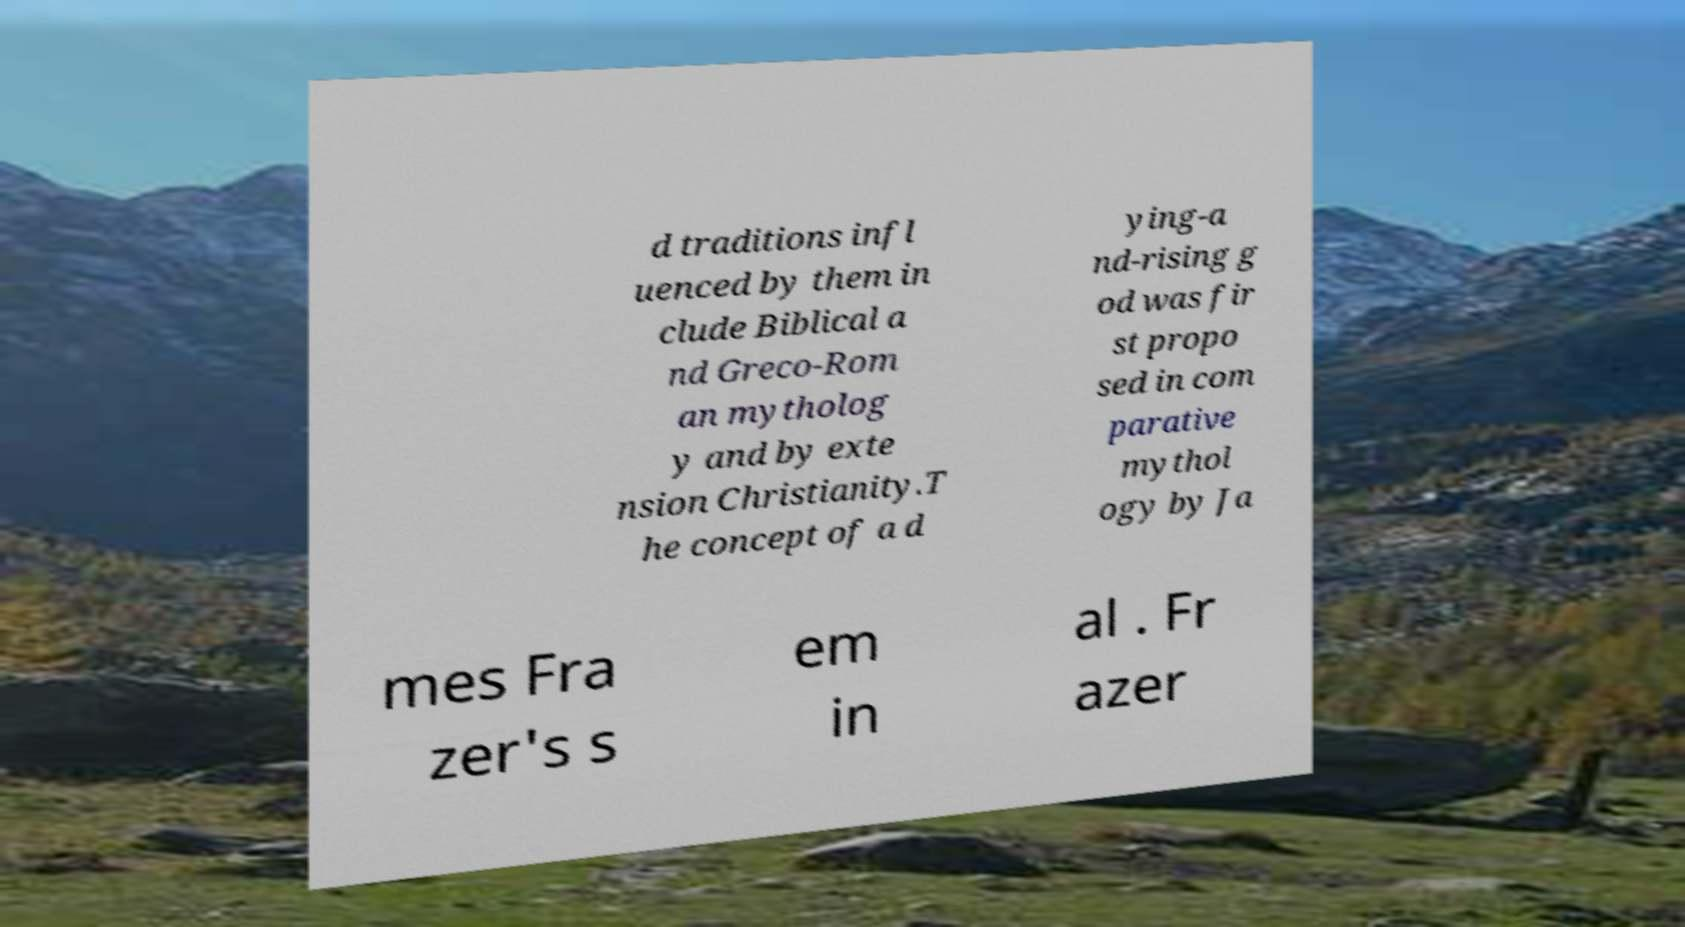Please read and relay the text visible in this image. What does it say? d traditions infl uenced by them in clude Biblical a nd Greco-Rom an mytholog y and by exte nsion Christianity.T he concept of a d ying-a nd-rising g od was fir st propo sed in com parative mythol ogy by Ja mes Fra zer's s em in al . Fr azer 